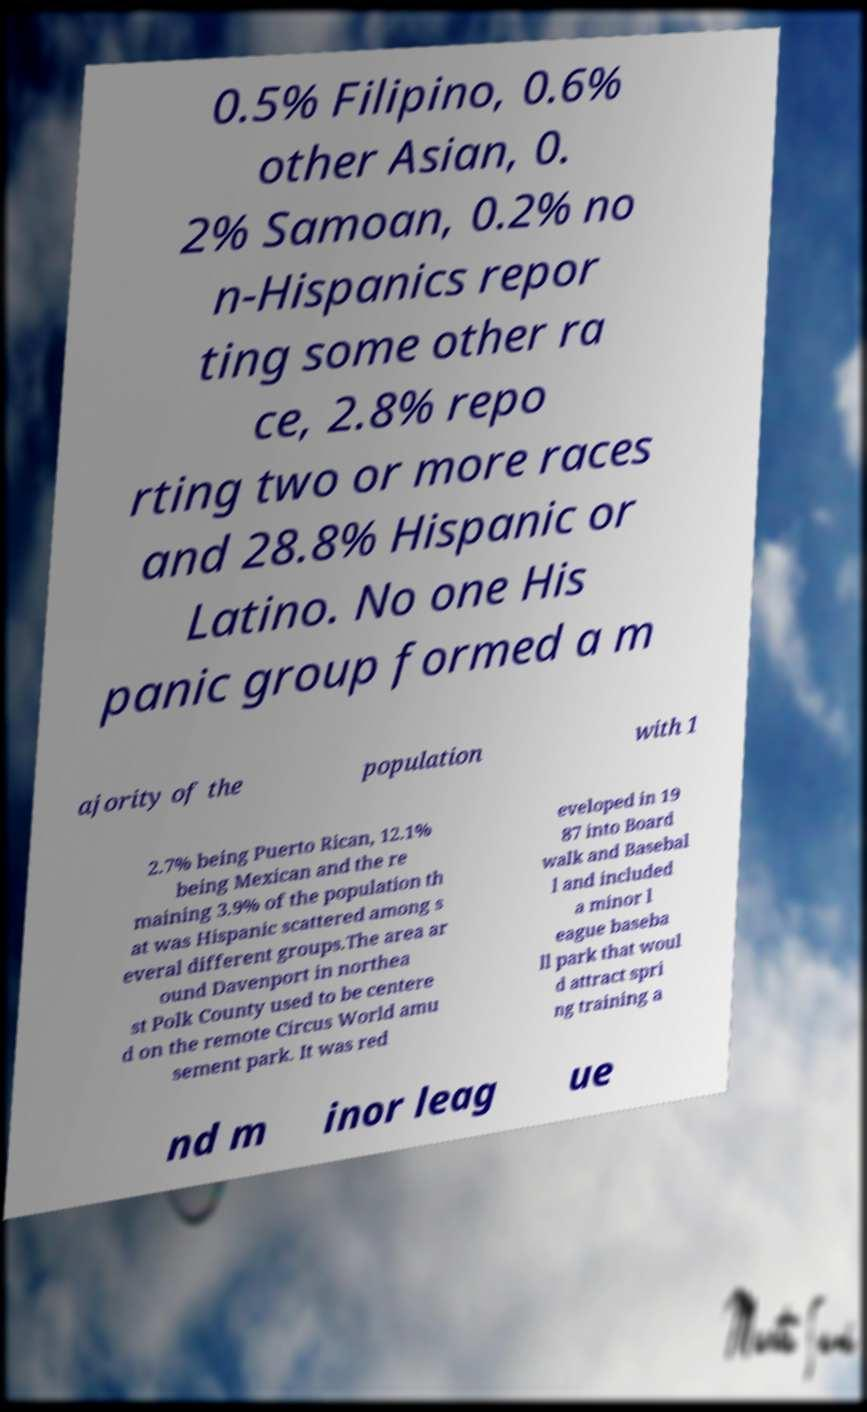For documentation purposes, I need the text within this image transcribed. Could you provide that? 0.5% Filipino, 0.6% other Asian, 0. 2% Samoan, 0.2% no n-Hispanics repor ting some other ra ce, 2.8% repo rting two or more races and 28.8% Hispanic or Latino. No one His panic group formed a m ajority of the population with 1 2.7% being Puerto Rican, 12.1% being Mexican and the re maining 3.9% of the population th at was Hispanic scattered among s everal different groups.The area ar ound Davenport in northea st Polk County used to be centere d on the remote Circus World amu sement park. It was red eveloped in 19 87 into Board walk and Basebal l and included a minor l eague baseba ll park that woul d attract spri ng training a nd m inor leag ue 